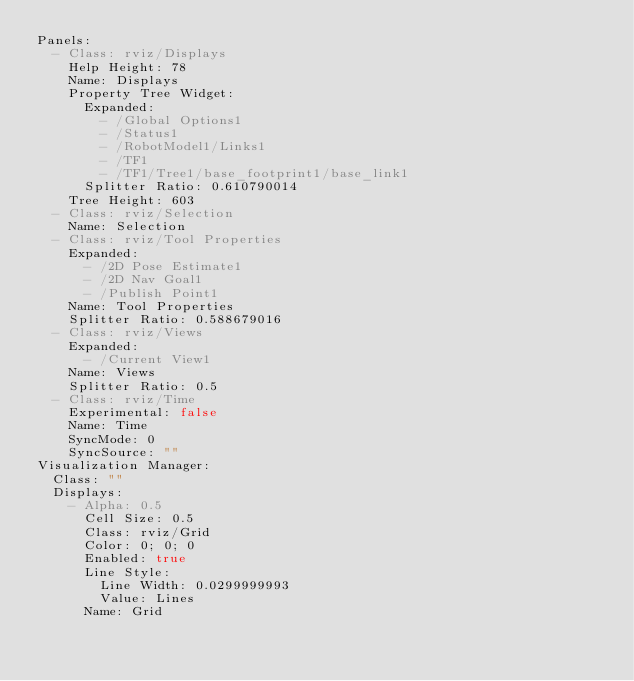Convert code to text. <code><loc_0><loc_0><loc_500><loc_500><_YAML_>Panels:
  - Class: rviz/Displays
    Help Height: 78
    Name: Displays
    Property Tree Widget:
      Expanded:
        - /Global Options1
        - /Status1
        - /RobotModel1/Links1
        - /TF1
        - /TF1/Tree1/base_footprint1/base_link1
      Splitter Ratio: 0.610790014
    Tree Height: 603
  - Class: rviz/Selection
    Name: Selection
  - Class: rviz/Tool Properties
    Expanded:
      - /2D Pose Estimate1
      - /2D Nav Goal1
      - /Publish Point1
    Name: Tool Properties
    Splitter Ratio: 0.588679016
  - Class: rviz/Views
    Expanded:
      - /Current View1
    Name: Views
    Splitter Ratio: 0.5
  - Class: rviz/Time
    Experimental: false
    Name: Time
    SyncMode: 0
    SyncSource: ""
Visualization Manager:
  Class: ""
  Displays:
    - Alpha: 0.5
      Cell Size: 0.5
      Class: rviz/Grid
      Color: 0; 0; 0
      Enabled: true
      Line Style:
        Line Width: 0.0299999993
        Value: Lines
      Name: Grid</code> 